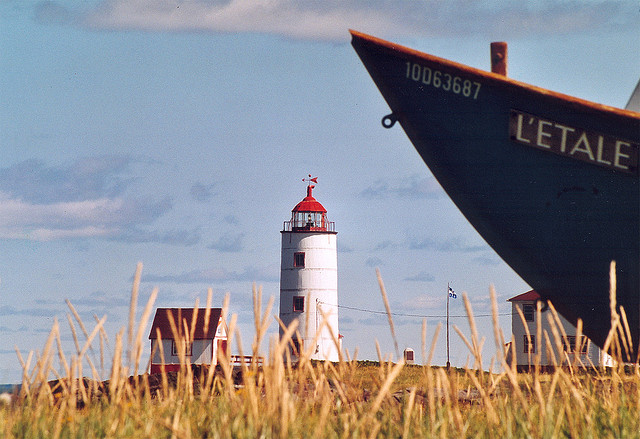<image>Why would there be a boat on land? It's unanswerable why there would be a boat on land without contextual information. It could possibly be for storage, for maintenance at a dry dock, or even part of a museum exhibit. Why would there be a boat on land? There can be several reasons why there would be a boat on land. Some possible reasons include: 
- People going out to sea later
- To store it
- For viewing
- It is dry docked
- It is a monument
- It is a museum exhibit
- It washed ashore
- It is for storage. 